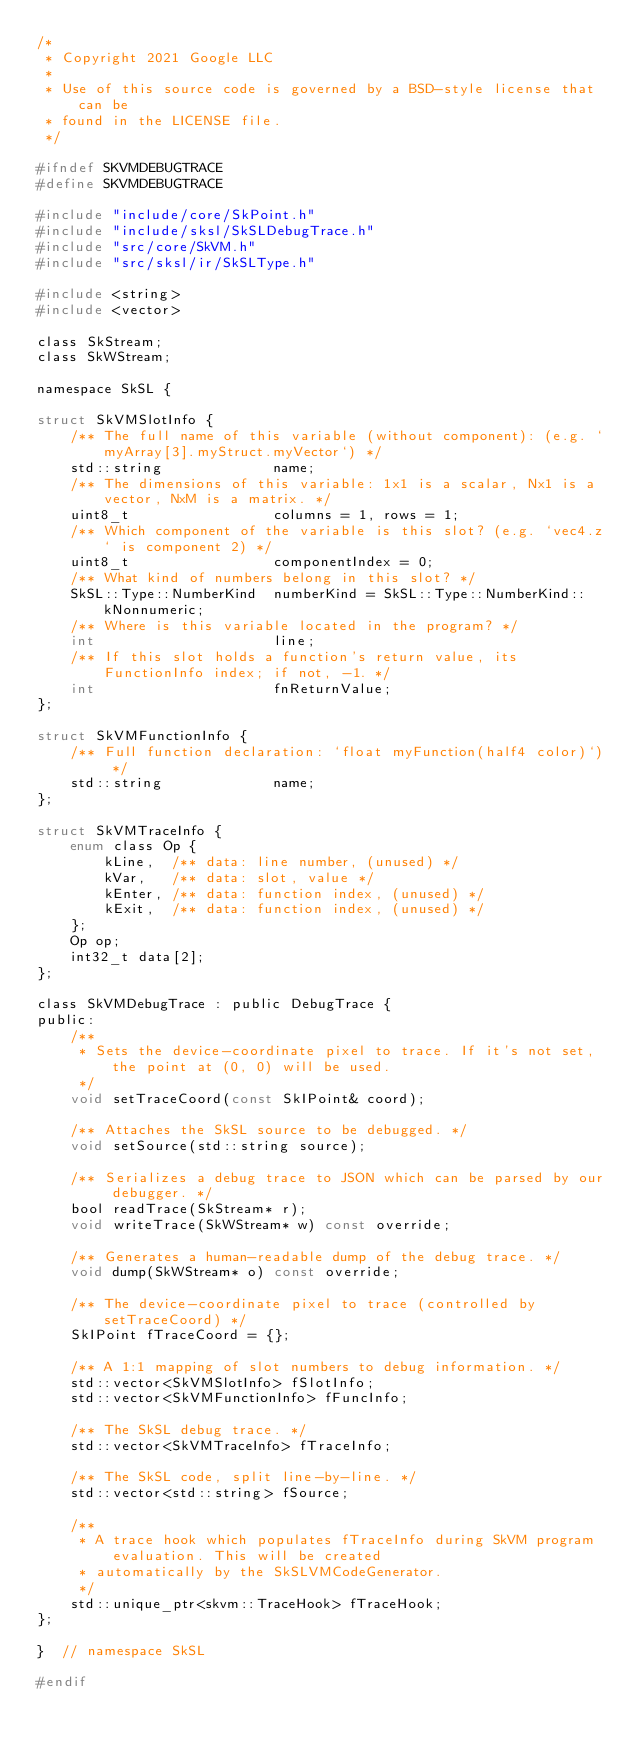Convert code to text. <code><loc_0><loc_0><loc_500><loc_500><_C_>/*
 * Copyright 2021 Google LLC
 *
 * Use of this source code is governed by a BSD-style license that can be
 * found in the LICENSE file.
 */

#ifndef SKVMDEBUGTRACE
#define SKVMDEBUGTRACE

#include "include/core/SkPoint.h"
#include "include/sksl/SkSLDebugTrace.h"
#include "src/core/SkVM.h"
#include "src/sksl/ir/SkSLType.h"

#include <string>
#include <vector>

class SkStream;
class SkWStream;

namespace SkSL {

struct SkVMSlotInfo {
    /** The full name of this variable (without component): (e.g. `myArray[3].myStruct.myVector`) */
    std::string             name;
    /** The dimensions of this variable: 1x1 is a scalar, Nx1 is a vector, NxM is a matrix. */
    uint8_t                 columns = 1, rows = 1;
    /** Which component of the variable is this slot? (e.g. `vec4.z` is component 2) */
    uint8_t                 componentIndex = 0;
    /** What kind of numbers belong in this slot? */
    SkSL::Type::NumberKind  numberKind = SkSL::Type::NumberKind::kNonnumeric;
    /** Where is this variable located in the program? */
    int                     line;
    /** If this slot holds a function's return value, its FunctionInfo index; if not, -1. */
    int                     fnReturnValue;
};

struct SkVMFunctionInfo {
    /** Full function declaration: `float myFunction(half4 color)`) */
    std::string             name;
};

struct SkVMTraceInfo {
    enum class Op {
        kLine,  /** data: line number, (unused) */
        kVar,   /** data: slot, value */
        kEnter, /** data: function index, (unused) */
        kExit,  /** data: function index, (unused) */
    };
    Op op;
    int32_t data[2];
};

class SkVMDebugTrace : public DebugTrace {
public:
    /**
     * Sets the device-coordinate pixel to trace. If it's not set, the point at (0, 0) will be used.
     */
    void setTraceCoord(const SkIPoint& coord);

    /** Attaches the SkSL source to be debugged. */
    void setSource(std::string source);

    /** Serializes a debug trace to JSON which can be parsed by our debugger. */
    bool readTrace(SkStream* r);
    void writeTrace(SkWStream* w) const override;

    /** Generates a human-readable dump of the debug trace. */
    void dump(SkWStream* o) const override;

    /** The device-coordinate pixel to trace (controlled by setTraceCoord) */
    SkIPoint fTraceCoord = {};

    /** A 1:1 mapping of slot numbers to debug information. */
    std::vector<SkVMSlotInfo> fSlotInfo;
    std::vector<SkVMFunctionInfo> fFuncInfo;

    /** The SkSL debug trace. */
    std::vector<SkVMTraceInfo> fTraceInfo;

    /** The SkSL code, split line-by-line. */
    std::vector<std::string> fSource;

    /**
     * A trace hook which populates fTraceInfo during SkVM program evaluation. This will be created
     * automatically by the SkSLVMCodeGenerator.
     */
    std::unique_ptr<skvm::TraceHook> fTraceHook;
};

}  // namespace SkSL

#endif
</code> 